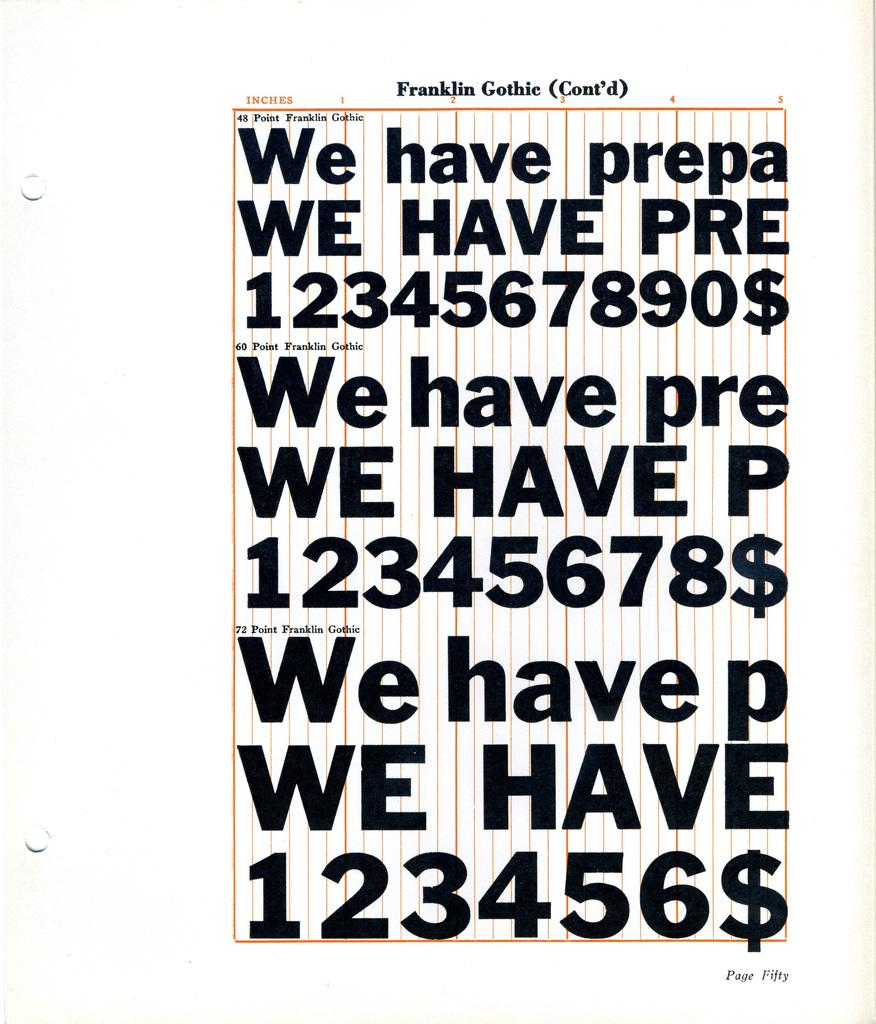Provide a one-sentence caption for the provided image. A font called Franklin Gothic is displayed in different sizes. 